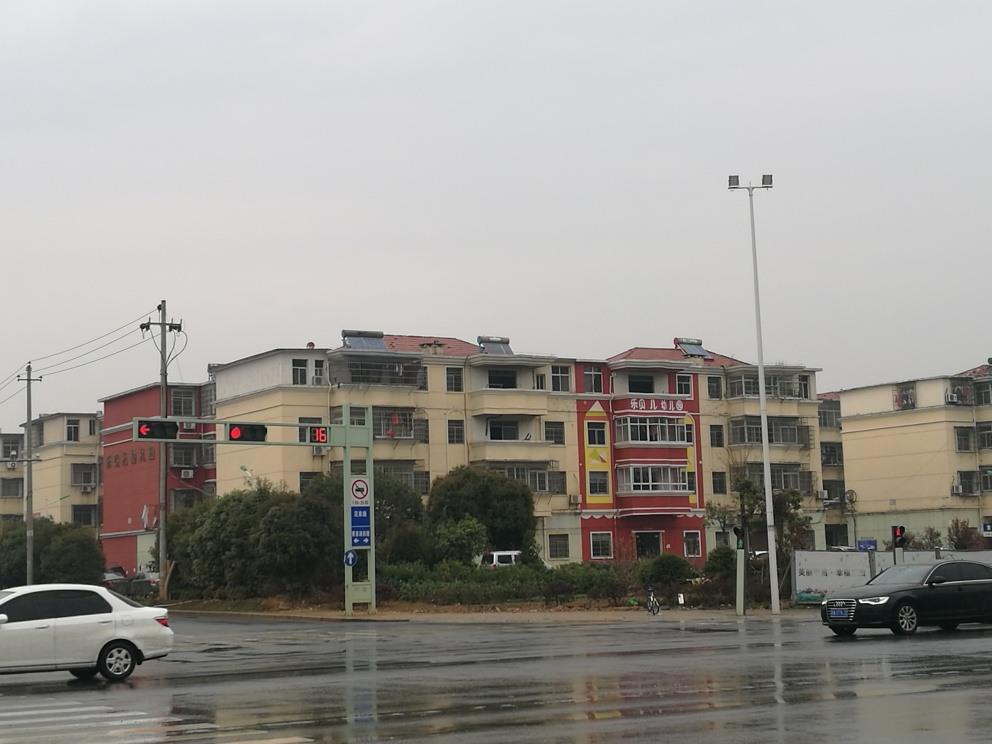Looking at the buildings, what can you infer about the architectural style or the age of the structures? The buildings feature a relatively simple architectural style with functional, straight lines and modest exterior embellishments. It is evident that the buildings are multi-unit residential structures, possibly with retail spaces at the ground level, as indicated by the signage. The style and condition of the buildings suggest they may not be very new but are likely not historical either — suggesting an age that could range from a few decades to more recent years. Despite this, there's no overt indication of significant disrepair, which means they are likely maintained. 